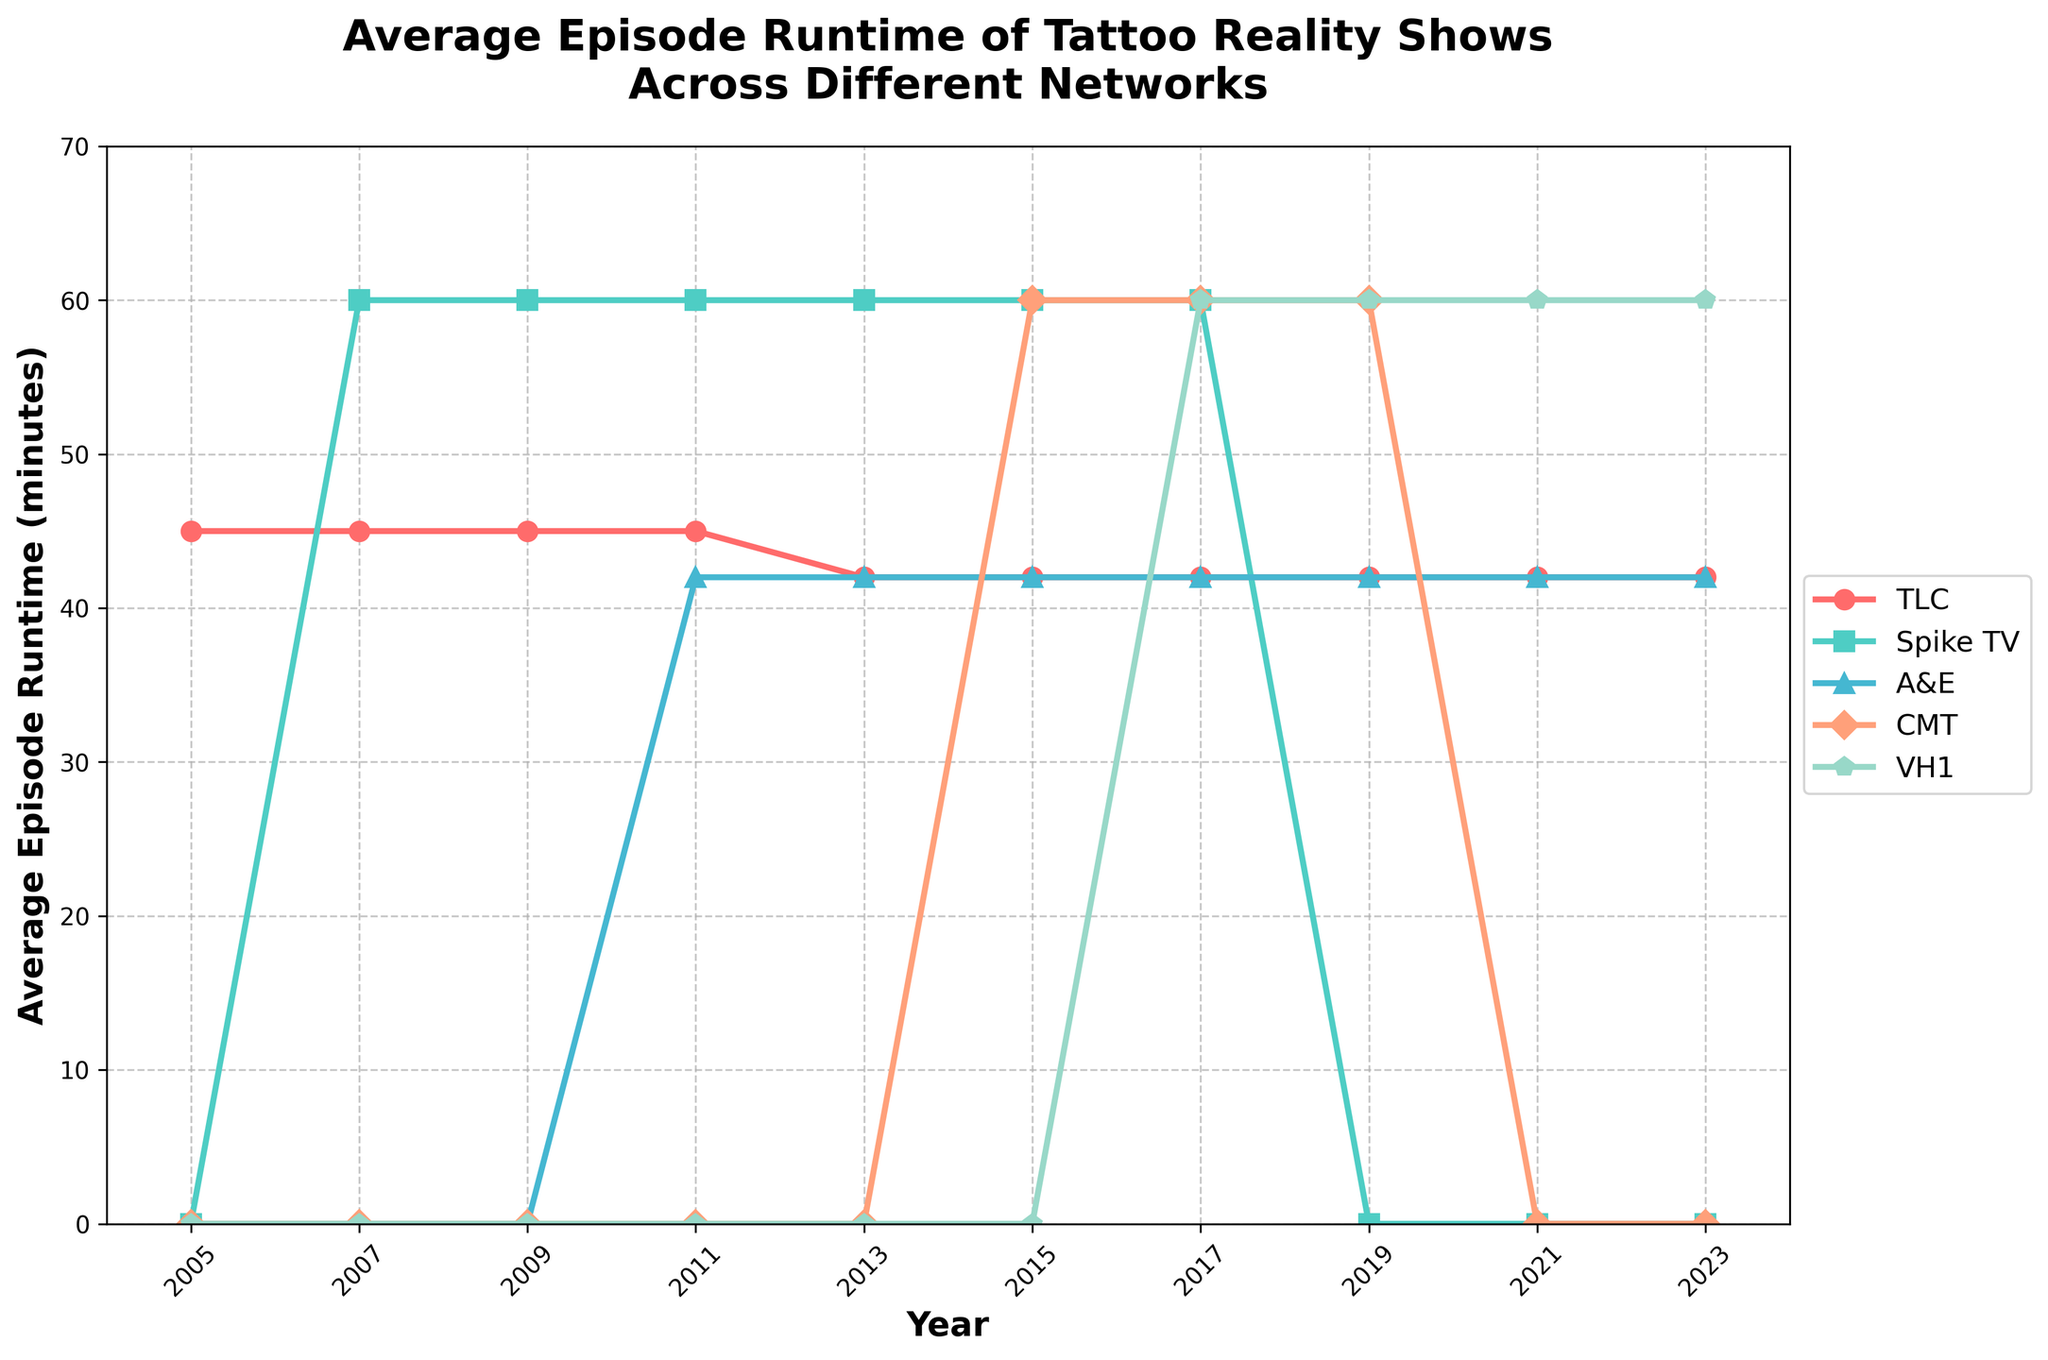What was the approximate runtime for TLC in 2011, and how does it compare to A&E in the same year? Refer to the point corresponding to the year 2011 on the x-axis and check the TLC and A&E lines. TLC shows 45 minutes, and A&E shows 42 minutes. Compare these values.
Answer: TLC: 45 minutes. A&E: 42 minutes. TLC is 3 minutes more Which network had the longest runtime in 2013? Look at the lines corresponding to 2013 and find the highest point among the networks. Spike TV has a runtime of 60 minutes.
Answer: Spike TV In which years did VH1 have an increasing trend in episode runtime? Observe the points corresponding to VH1 and identify the years where the line increases. The runtime increases from 0 in 2015 to 60 in 2017 and remains constant afterward.
Answer: From 2015 to 2017 What is the total runtime difference between the highest and lowest networks in 2019? Find the highest and lowest points for the year 2019. VH1 has 60 minutes, and TLC has 42 minutes. Subtract the lower value from the higher one.
Answer: 18 minutes Compare the average runtime for TLC between 2005 and 2023. How has it changed over this period? Calculate the average runtime for TLC in 2005 and 2023. In both years, TLC has a runtime of 42 minutes. So, no change.
Answer: No change, both 42 minutes Which network had a new entry in 2015, and what was its initial runtime? Check the data points and see which network appears for the first time in 2015. CMT appears with an initial runtime of 60 minutes.
Answer: CMT with 60 minutes Did Spike TV have any years with zero runtime? Scan through the figure to see if the line representing Spike TV ever hits zero. In 2019, 2021, and 2023, it's at zero.
Answer: Yes, in 2019, 2021, and 2023 How many networks maintained a constant runtime from their entry until 2023? Check the runtime of each network from their start to 2023. TLC maintained at 42 minutes, A&E at 42 since 2011, and VH1 at 60 since 2017.
Answer: Three networks (TLC, A&E, and VH1) In what year did A&E and CMT both share the same runtime, and what was it? Find the year where both A&E and CMT show the same value on the y-axis, which is 2015 with 60 minutes each.
Answer: 2015, 60 minutes 